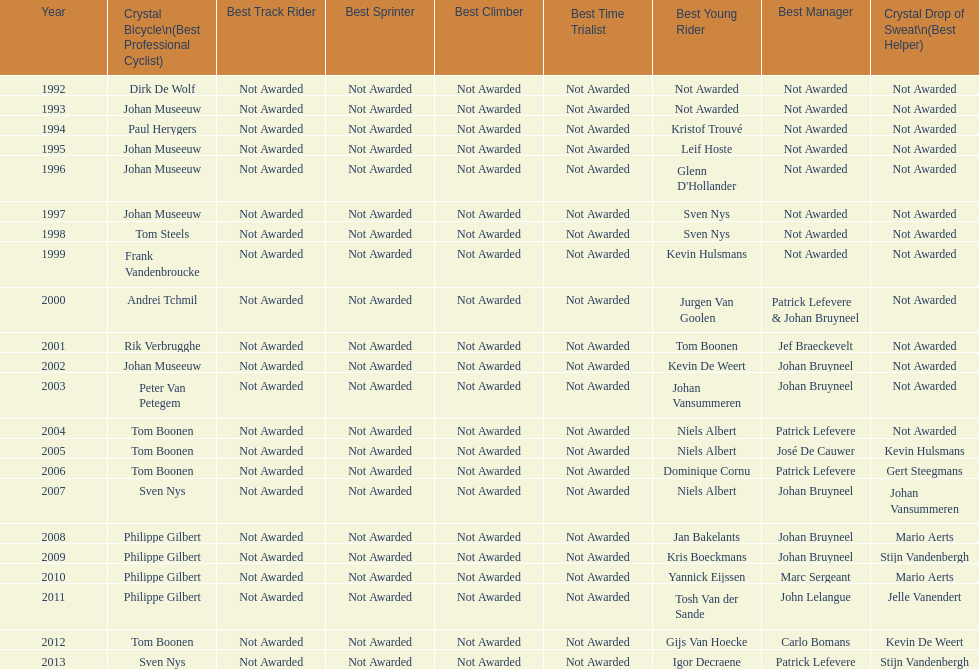What is the average number of times johan museeuw starred? 5. 